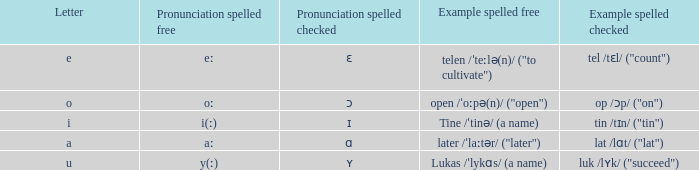What is Pronunciation Spelled Free, when Pronunciation Spelled Checked is "ʏ"? Y(ː). 